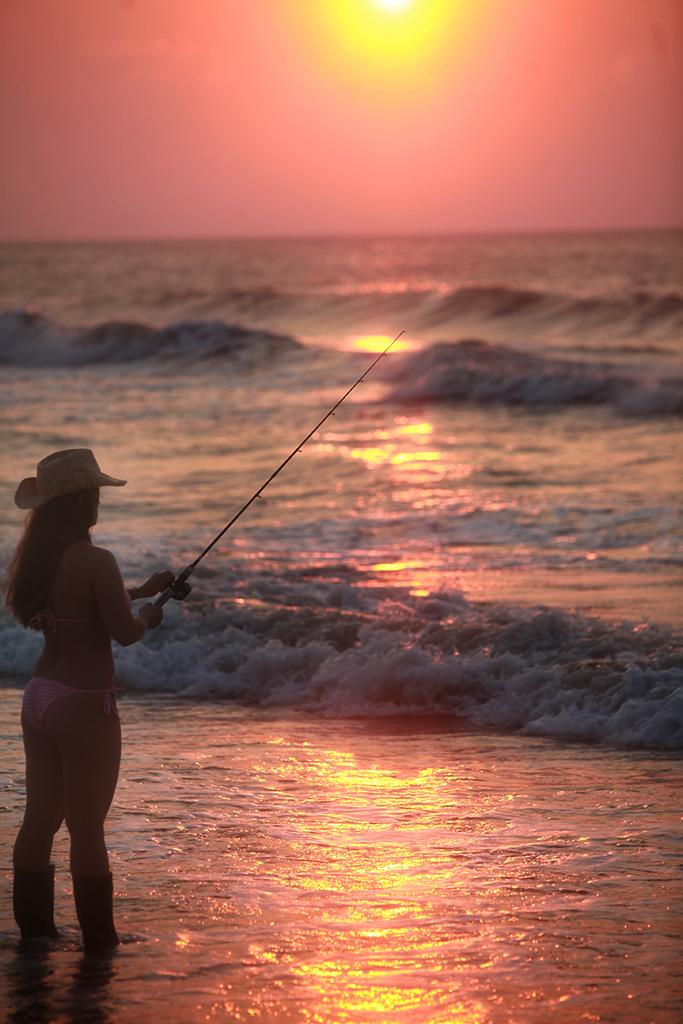What is the main subject of the image? There is a person standing in the center of the image. What is the person holding in the image? The person is holding a fishing rod. What can be seen in the background of the image? There is sky and water visible in the background of the image. Can the sun be seen in the sky? Yes, the sun is observable in the sky. What book is the person reading in the image? There is no book present in the image; the person is holding a fishing rod. How many waves can be seen in the water in the image? There is no mention of waves in the image; only water is visible in the background. 